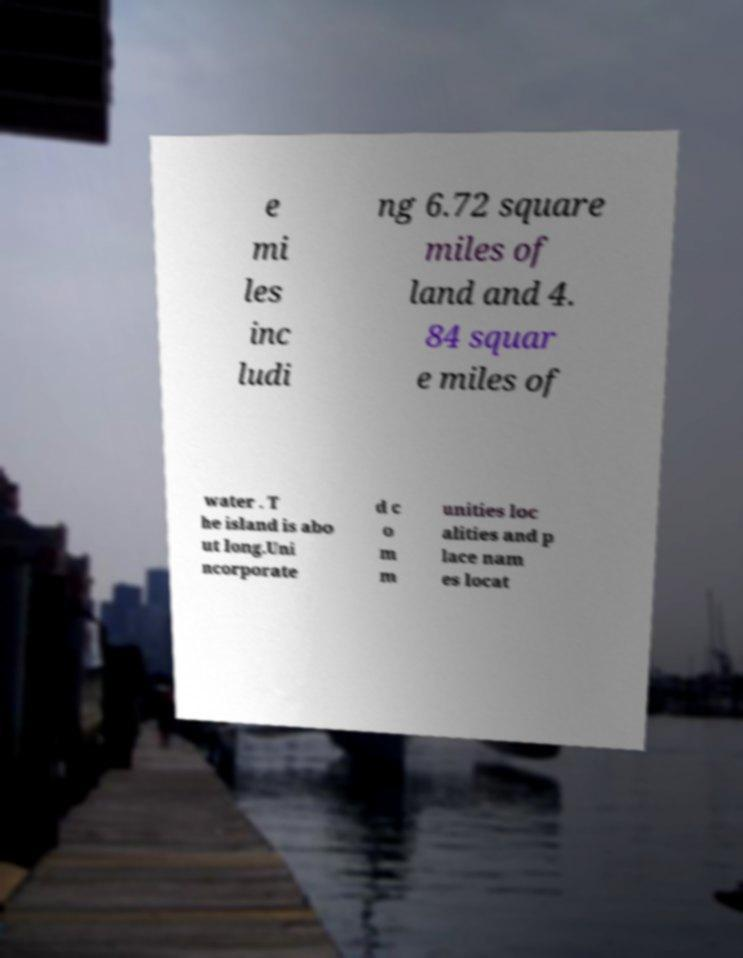Can you read and provide the text displayed in the image?This photo seems to have some interesting text. Can you extract and type it out for me? e mi les inc ludi ng 6.72 square miles of land and 4. 84 squar e miles of water . T he island is abo ut long.Uni ncorporate d c o m m unities loc alities and p lace nam es locat 